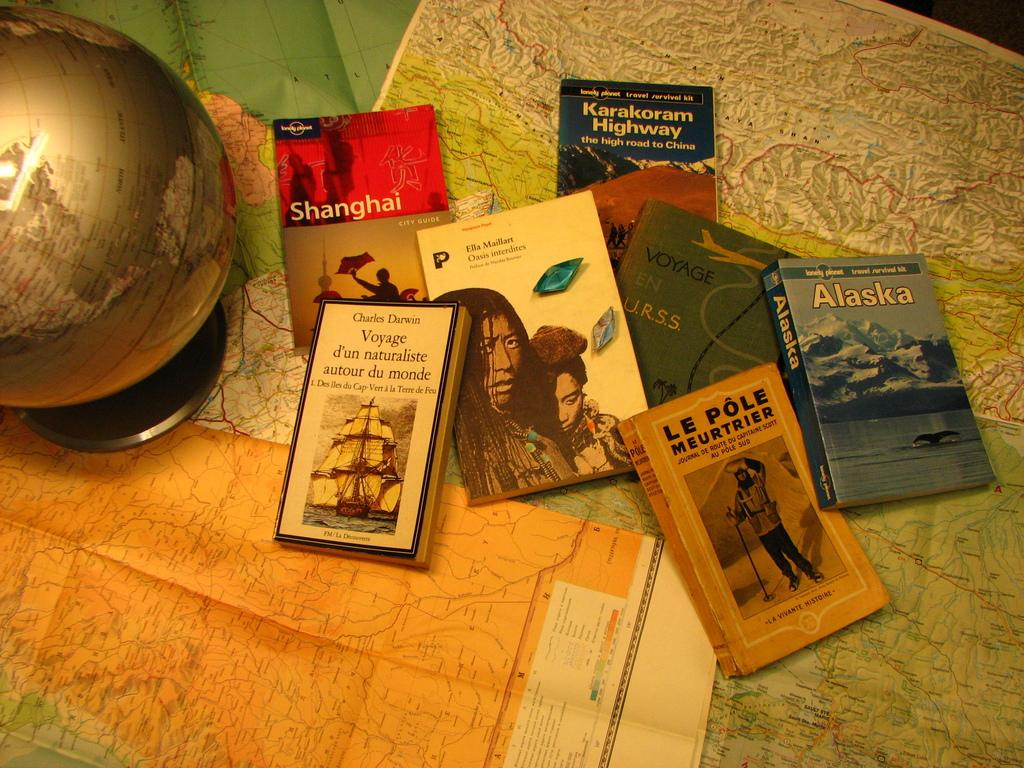<image>
Give a short and clear explanation of the subsequent image. A collection of books about travel to places such as Alaska and Shanghai on top of maps and next to a globe. 